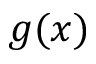Convert formula to latex. <formula><loc_0><loc_0><loc_500><loc_500>g ( x )</formula> 